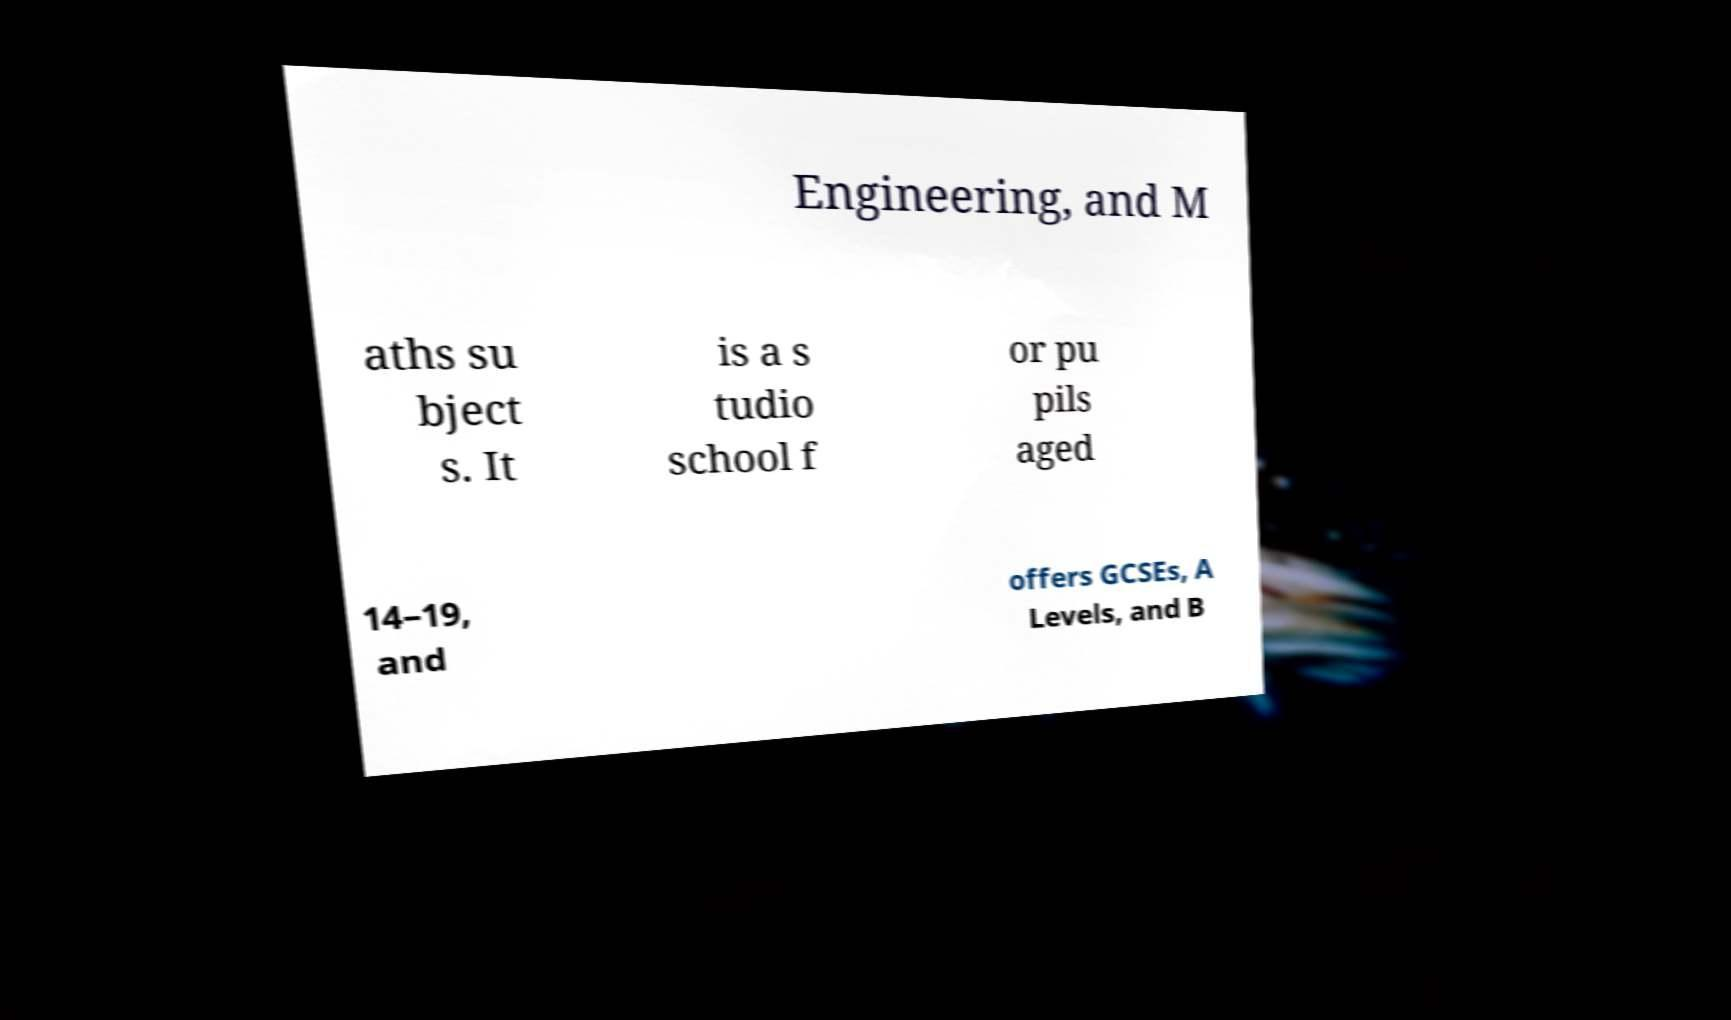What messages or text are displayed in this image? I need them in a readable, typed format. Engineering, and M aths su bject s. It is a s tudio school f or pu pils aged 14–19, and offers GCSEs, A Levels, and B 